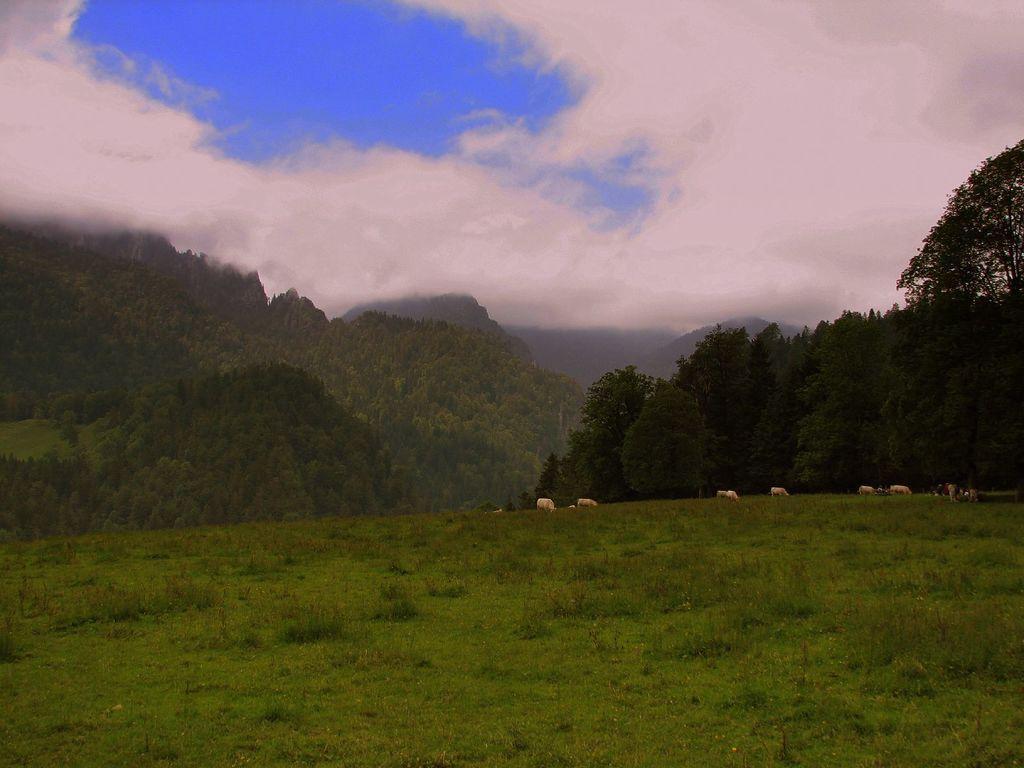Could you give a brief overview of what you see in this image? In this image we can see cattle grazing the grass, trees, hills and sky with clouds. 